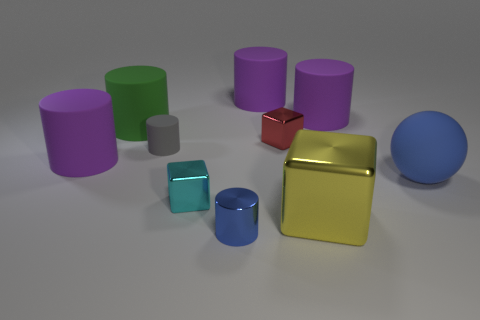Subtract all cyan blocks. How many purple cylinders are left? 3 Subtract 1 cylinders. How many cylinders are left? 5 Subtract all tiny blue metallic cylinders. How many cylinders are left? 5 Subtract all gray cylinders. How many cylinders are left? 5 Subtract all green cylinders. Subtract all blue spheres. How many cylinders are left? 5 Subtract all cubes. How many objects are left? 7 Subtract all large objects. Subtract all big purple matte things. How many objects are left? 1 Add 6 purple cylinders. How many purple cylinders are left? 9 Add 4 large red spheres. How many large red spheres exist? 4 Subtract 0 cyan balls. How many objects are left? 10 